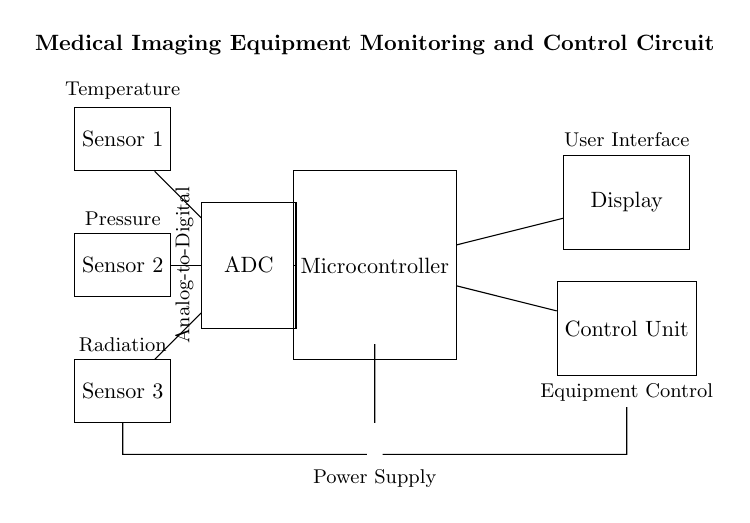What is the role of the microcontroller? The microcontroller processes the data from the sensors and controls the display and control unit. It acts as the brain of the circuit.
Answer: Processing What type of sensors are used in this circuit? The circuit includes temperature, pressure, and radiation sensors, which provide specific medical imaging data to the system.
Answer: Temperature, pressure, radiation What is the function of the ADC? The ADC converts the analog signals from the sensors into digital signals that can be processed by the microcontroller.
Answer: Analog-to-Digital conversion How many sensors are connected to the ADC? There are three sensors connected to the ADC, with each sensor measuring a different parameter relevant to medical imaging.
Answer: Three Which component is responsible for displaying user data? The display unit is responsible for presenting the processed data to the user, facilitating interaction with the equipment.
Answer: Display What is the power source for the circuit? The power supply for the circuit comes from a battery, providing the necessary energy for the entire system to operate.
Answer: Battery What actions does the control unit perform? The control unit executes commands based on the processed data from the microcontroller, effectively controlling the medical imaging equipment’s operation.
Answer: Equipment control 